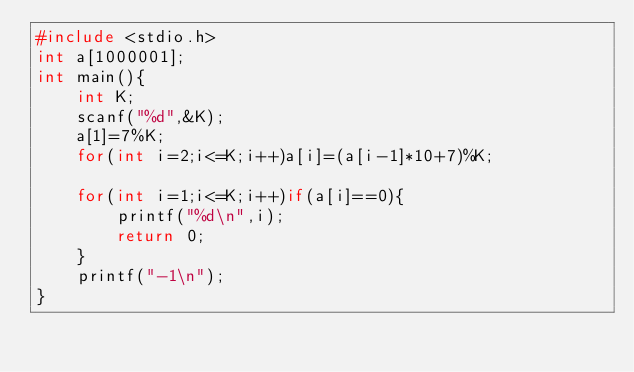<code> <loc_0><loc_0><loc_500><loc_500><_C++_>#include <stdio.h>
int a[1000001];
int main(){
    int K;
    scanf("%d",&K);
    a[1]=7%K;
    for(int i=2;i<=K;i++)a[i]=(a[i-1]*10+7)%K;

    for(int i=1;i<=K;i++)if(a[i]==0){
        printf("%d\n",i);
        return 0;
    }
    printf("-1\n");
}</code> 